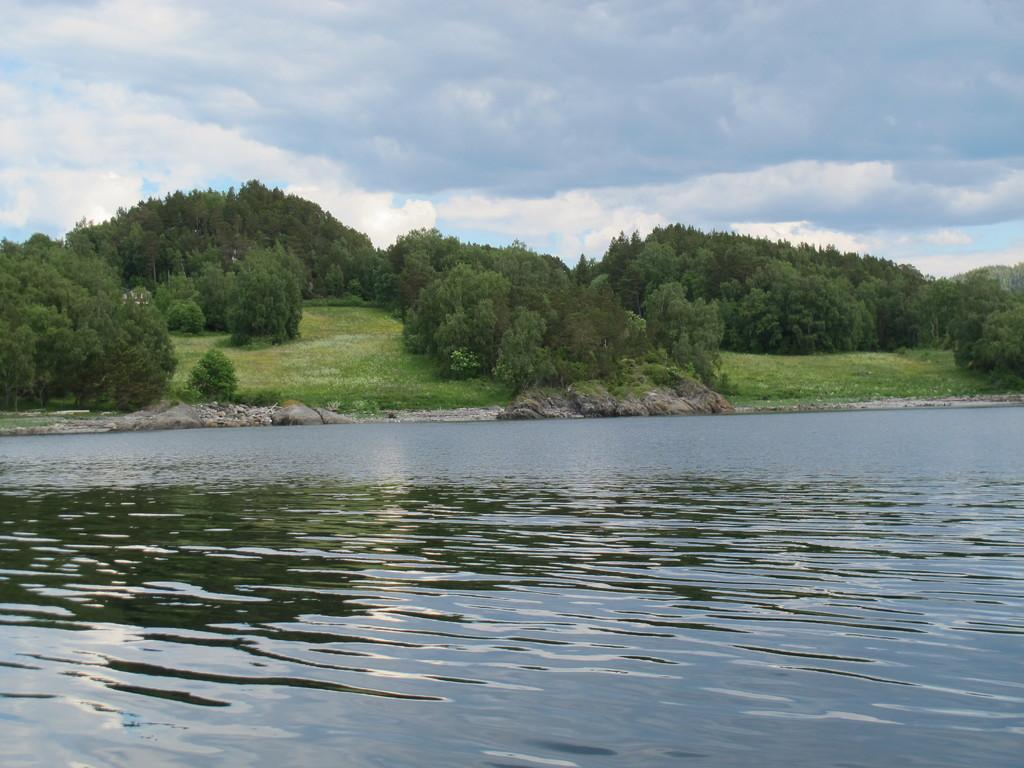What is visible in the image? Water, rocks, trees, grass, and the sky are visible in the image. Can you describe the ground in the image? The ground in the image is covered with grass. What is visible in the sky in the image? Clouds are present in the sky in the image. What degree does the animal in the image have? There is no animal present in the image, so it is not possible to determine the degree they might have. 